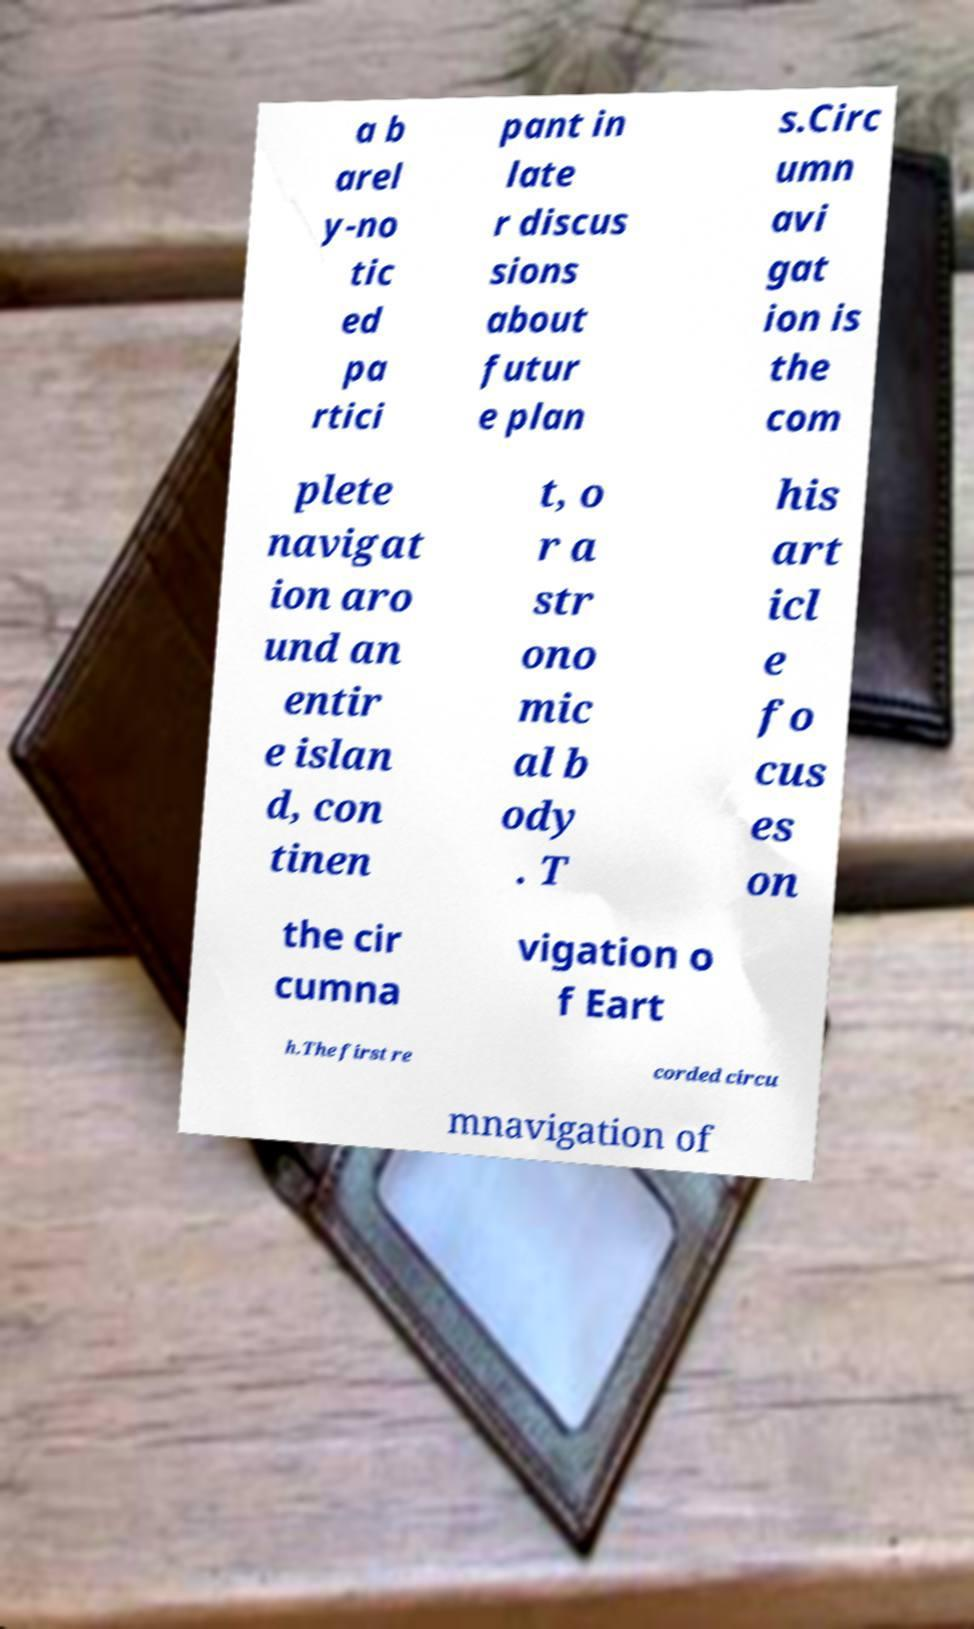I need the written content from this picture converted into text. Can you do that? a b arel y-no tic ed pa rtici pant in late r discus sions about futur e plan s.Circ umn avi gat ion is the com plete navigat ion aro und an entir e islan d, con tinen t, o r a str ono mic al b ody . T his art icl e fo cus es on the cir cumna vigation o f Eart h.The first re corded circu mnavigation of 